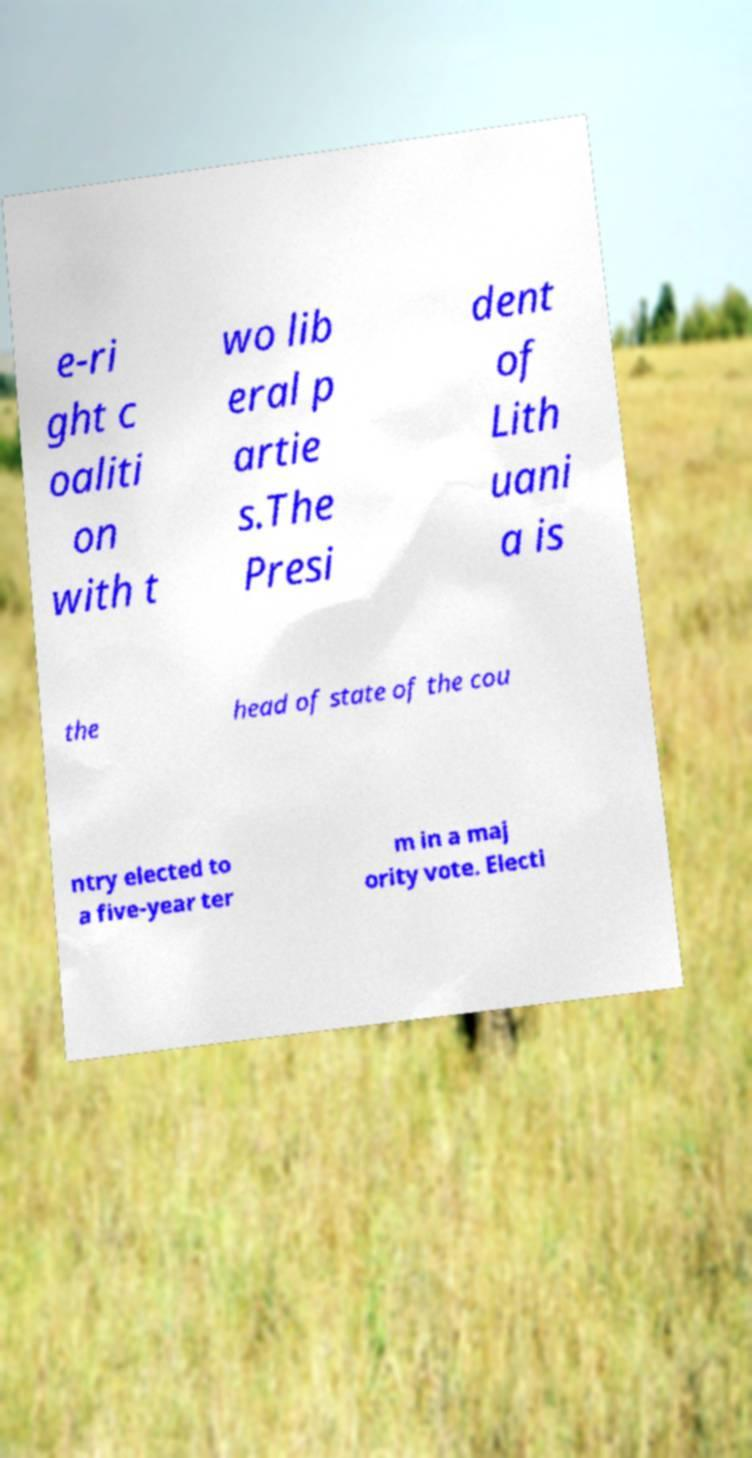Could you extract and type out the text from this image? e-ri ght c oaliti on with t wo lib eral p artie s.The Presi dent of Lith uani a is the head of state of the cou ntry elected to a five-year ter m in a maj ority vote. Electi 